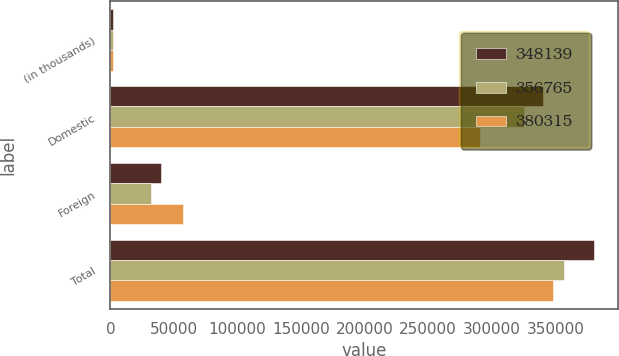Convert chart. <chart><loc_0><loc_0><loc_500><loc_500><stacked_bar_chart><ecel><fcel>(in thousands)<fcel>Domestic<fcel>Foreign<fcel>Total<nl><fcel>348139<fcel>2016<fcel>340251<fcel>40064<fcel>380315<nl><fcel>356765<fcel>2015<fcel>325097<fcel>31668<fcel>356765<nl><fcel>380315<fcel>2014<fcel>291042<fcel>57097<fcel>348139<nl></chart> 